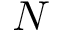Convert formula to latex. <formula><loc_0><loc_0><loc_500><loc_500>N</formula> 